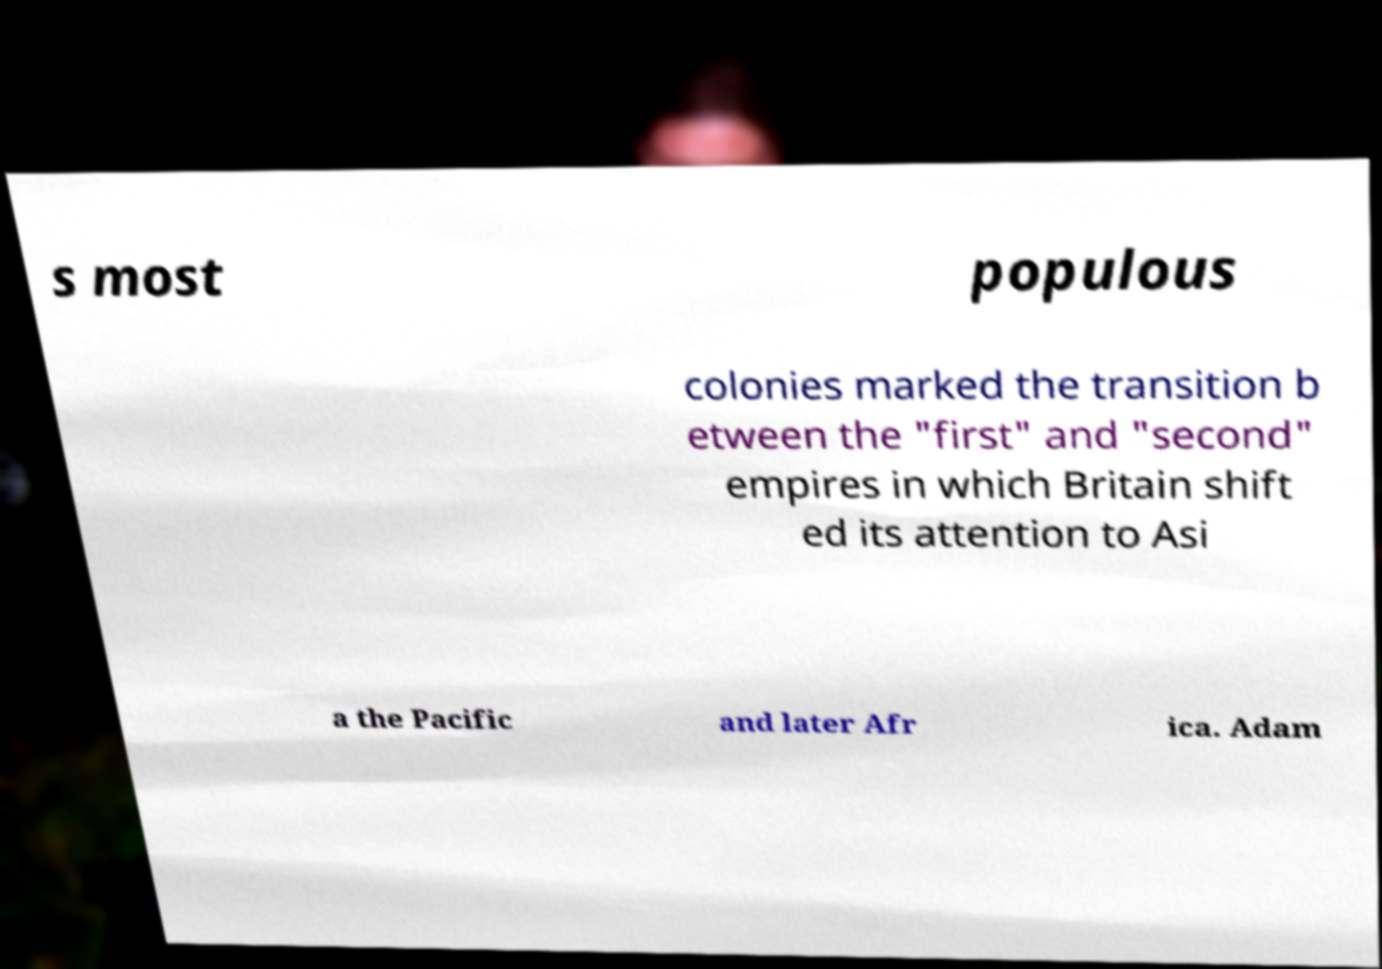Could you extract and type out the text from this image? s most populous colonies marked the transition b etween the "first" and "second" empires in which Britain shift ed its attention to Asi a the Pacific and later Afr ica. Adam 